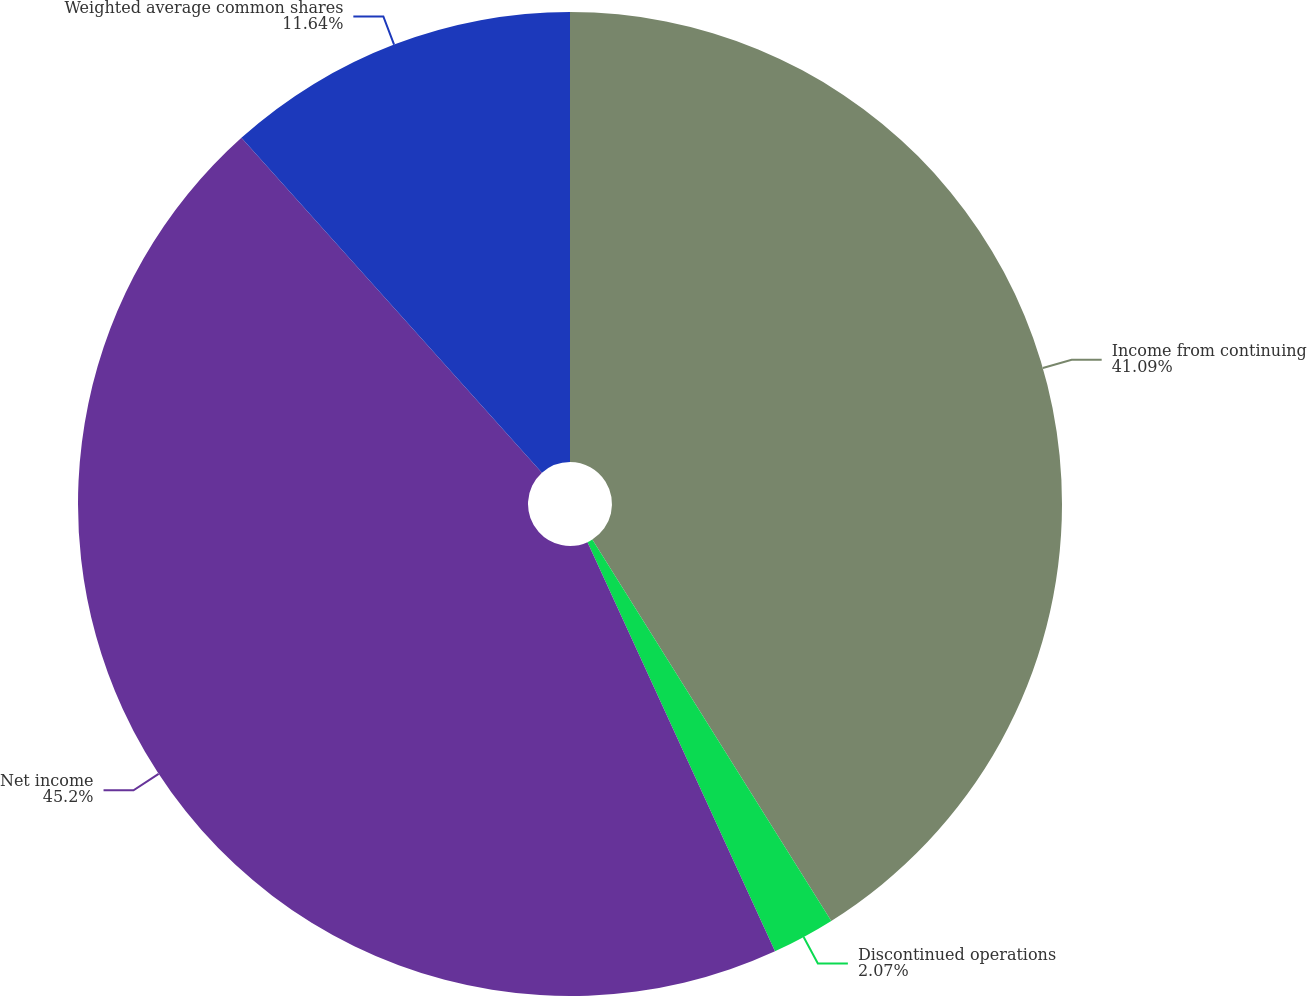Convert chart. <chart><loc_0><loc_0><loc_500><loc_500><pie_chart><fcel>Income from continuing<fcel>Discontinued operations<fcel>Net income<fcel>Weighted average common shares<nl><fcel>41.09%<fcel>2.07%<fcel>45.2%<fcel>11.64%<nl></chart> 